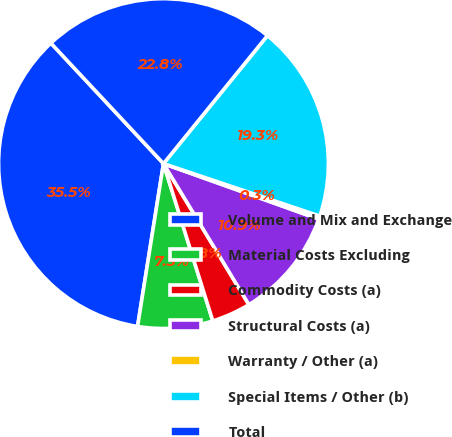Convert chart. <chart><loc_0><loc_0><loc_500><loc_500><pie_chart><fcel>Volume and Mix and Exchange<fcel>Material Costs Excluding<fcel>Commodity Costs (a)<fcel>Structural Costs (a)<fcel>Warranty / Other (a)<fcel>Special Items / Other (b)<fcel>Total<nl><fcel>35.53%<fcel>7.35%<fcel>3.83%<fcel>10.87%<fcel>0.31%<fcel>19.3%<fcel>22.82%<nl></chart> 